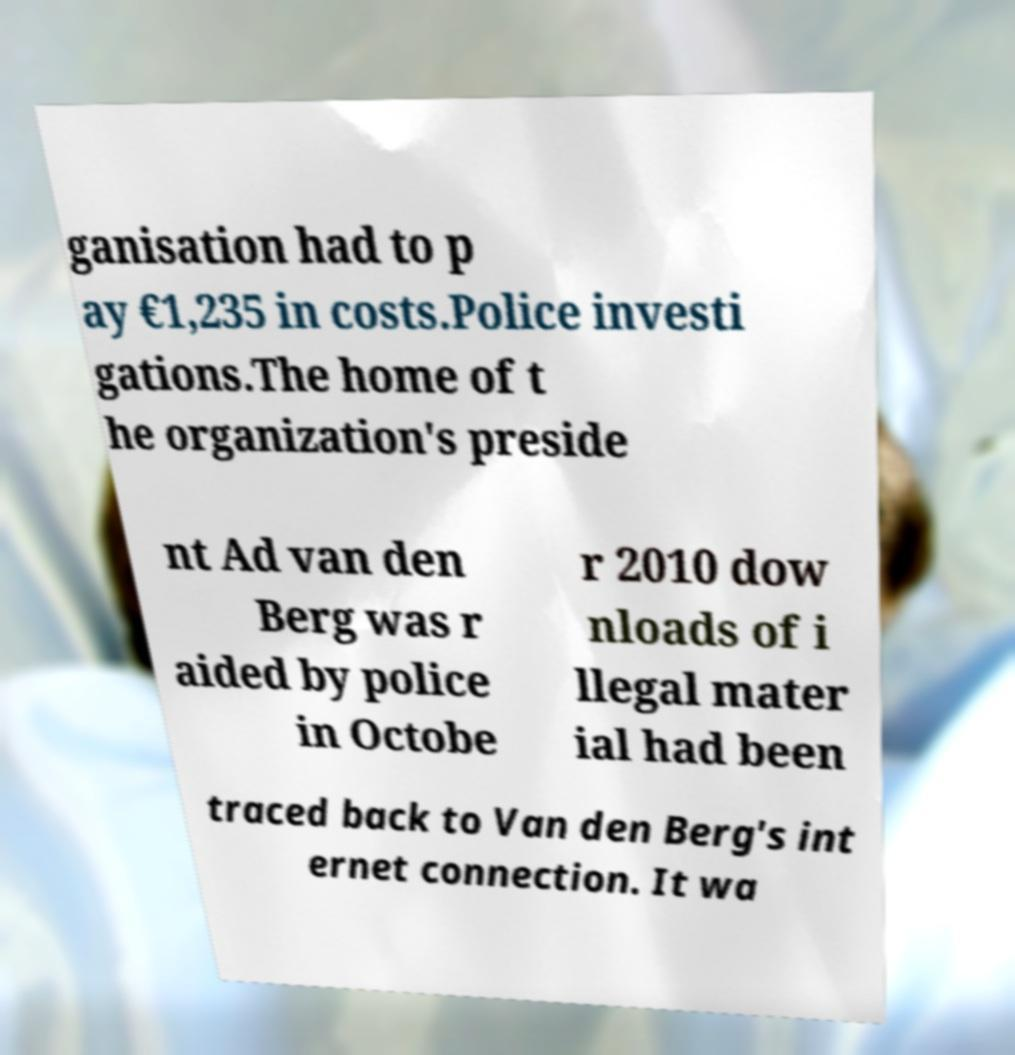There's text embedded in this image that I need extracted. Can you transcribe it verbatim? ganisation had to p ay €1,235 in costs.Police investi gations.The home of t he organization's preside nt Ad van den Berg was r aided by police in Octobe r 2010 dow nloads of i llegal mater ial had been traced back to Van den Berg's int ernet connection. It wa 